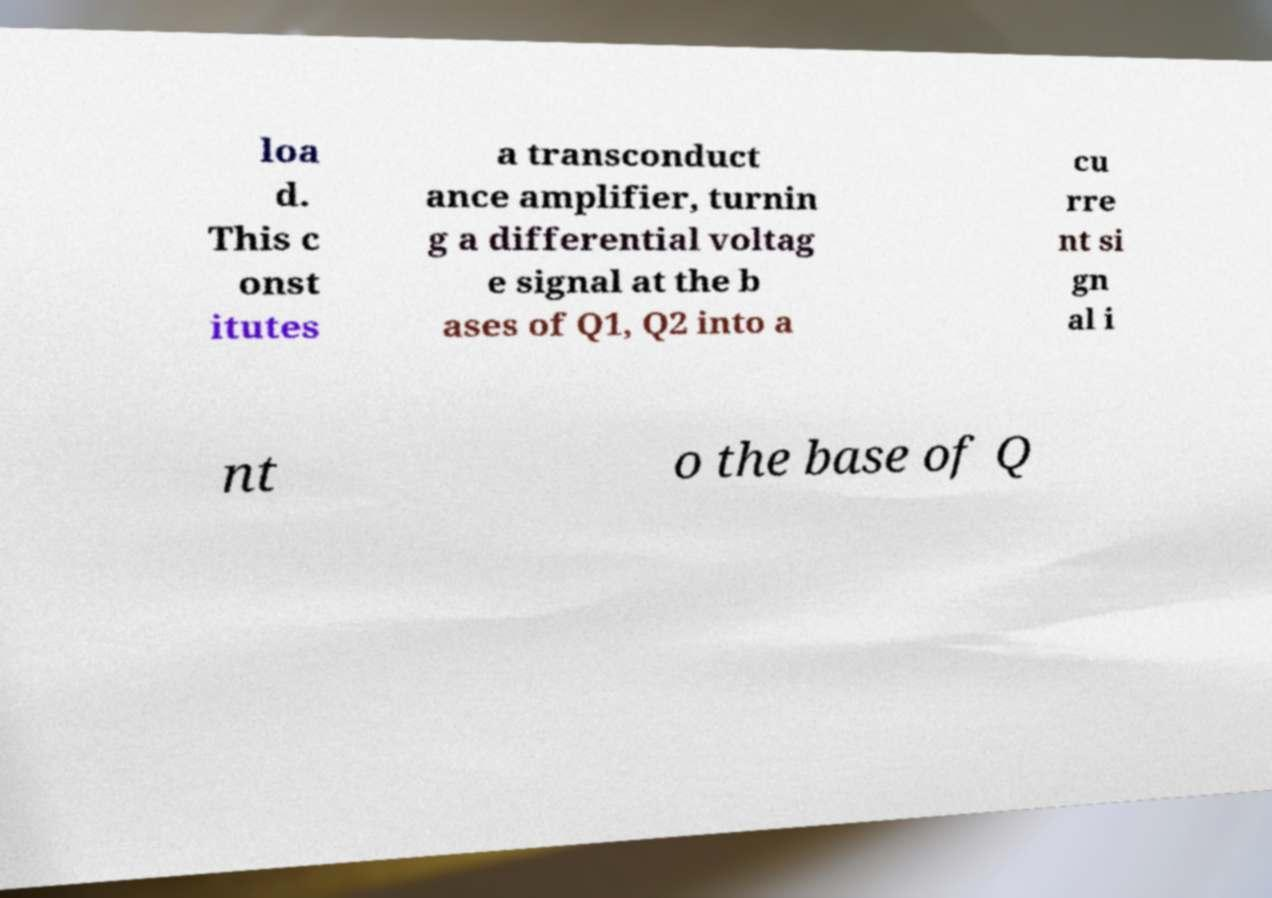Please identify and transcribe the text found in this image. loa d. This c onst itutes a transconduct ance amplifier, turnin g a differential voltag e signal at the b ases of Q1, Q2 into a cu rre nt si gn al i nt o the base of Q 